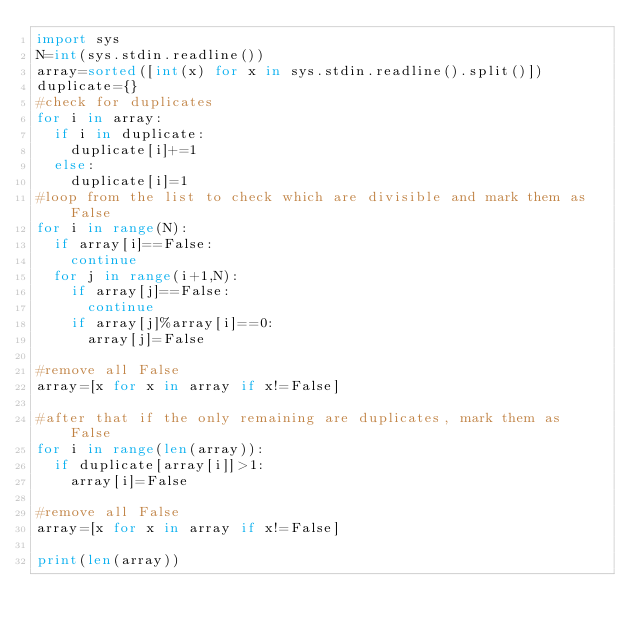<code> <loc_0><loc_0><loc_500><loc_500><_Python_>import sys
N=int(sys.stdin.readline())
array=sorted([int(x) for x in sys.stdin.readline().split()])
duplicate={}
#check for duplicates
for i in array:
	if i in duplicate:
		duplicate[i]+=1
	else:
		duplicate[i]=1
#loop from the list to check which are divisible and mark them as False
for i in range(N):
	if array[i]==False:
		continue
	for j in range(i+1,N):
		if array[j]==False:
			continue
		if array[j]%array[i]==0:
			array[j]=False

#remove all False
array=[x for x in array if x!=False]

#after that if the only remaining are duplicates, mark them as False
for i in range(len(array)):
	if duplicate[array[i]]>1:
		array[i]=False

#remove all False
array=[x for x in array if x!=False]

print(len(array))
</code> 